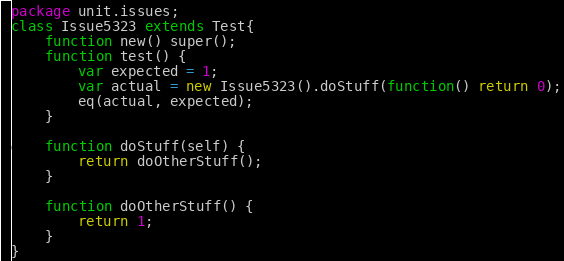<code> <loc_0><loc_0><loc_500><loc_500><_Haxe_>package unit.issues;
class Issue5323 extends Test{
	function new() super();
    function test() {
    	var expected = 1;
        var actual = new Issue5323().doStuff(function() return 0);
        eq(actual, expected);
    }

    function doStuff(self) {
        return doOtherStuff();
    }

    function doOtherStuff() {
    	return 1;
    }
}
</code> 